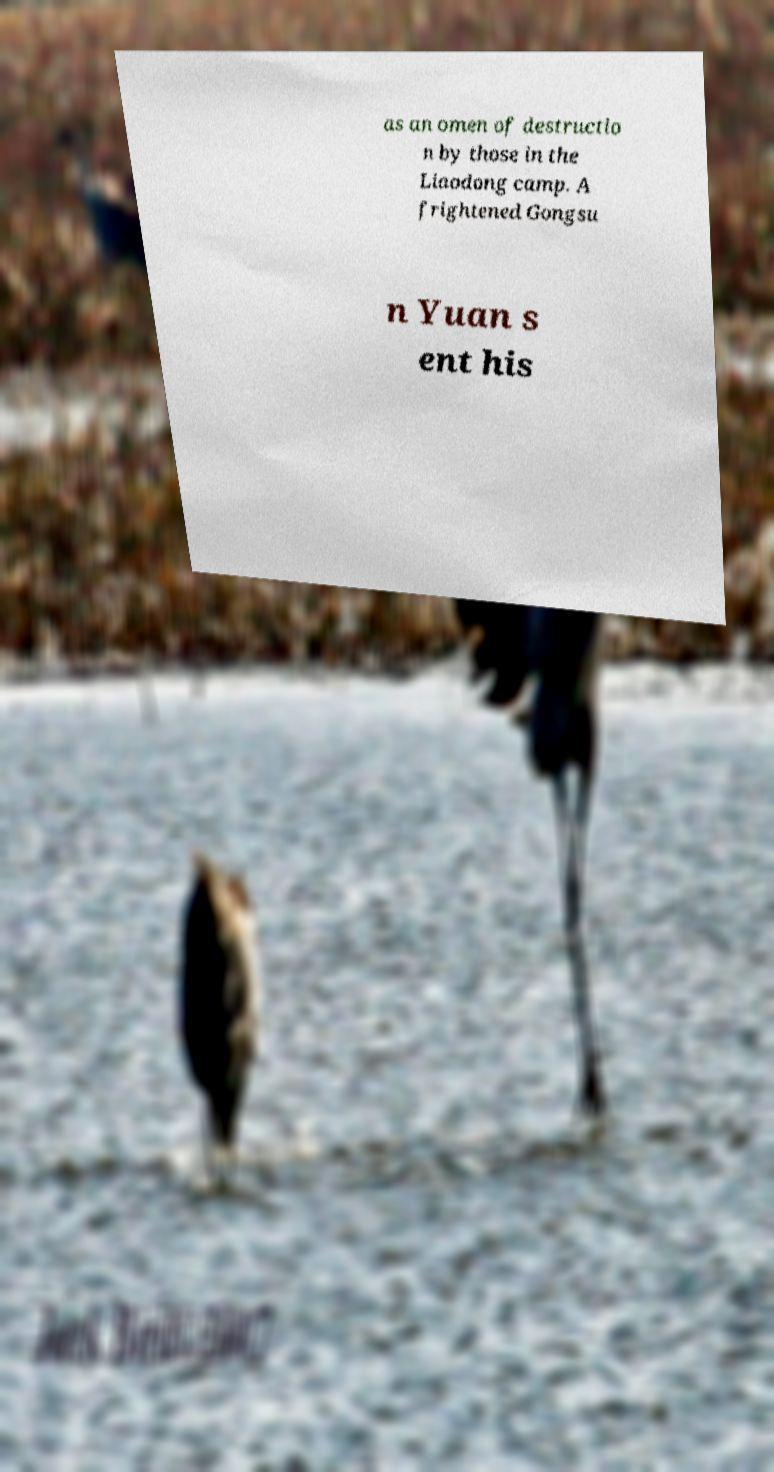Could you extract and type out the text from this image? as an omen of destructio n by those in the Liaodong camp. A frightened Gongsu n Yuan s ent his 